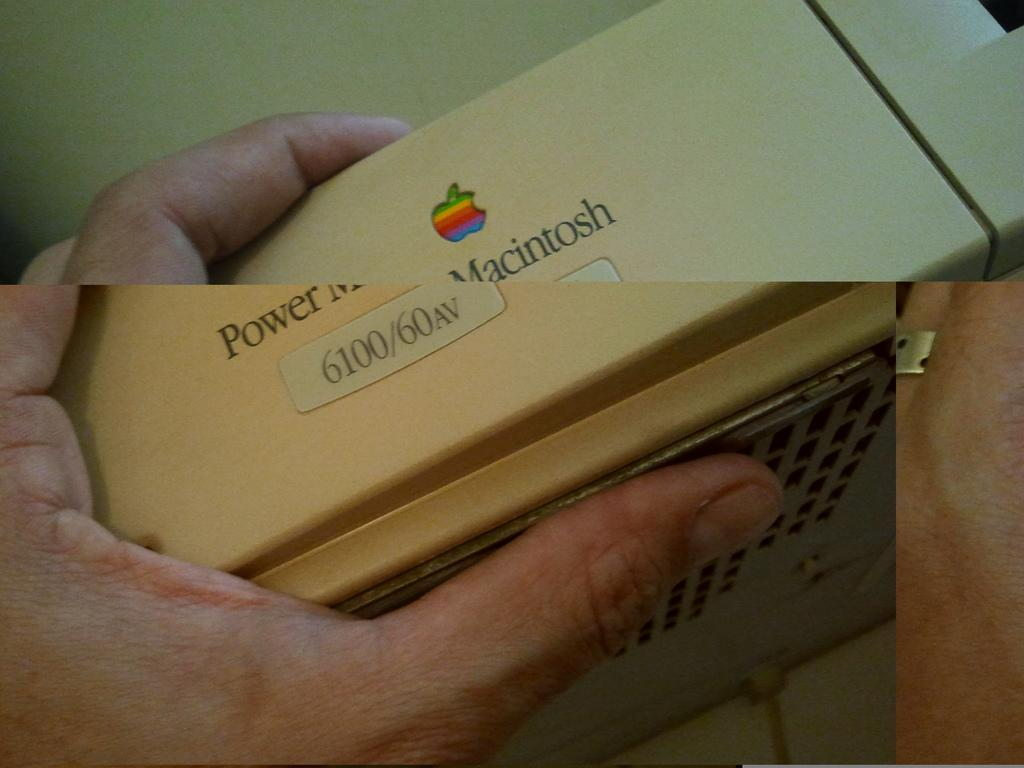Provide a one-sentence caption for the provided image. A person is holding an Apple computer that says Power Macintosh. 